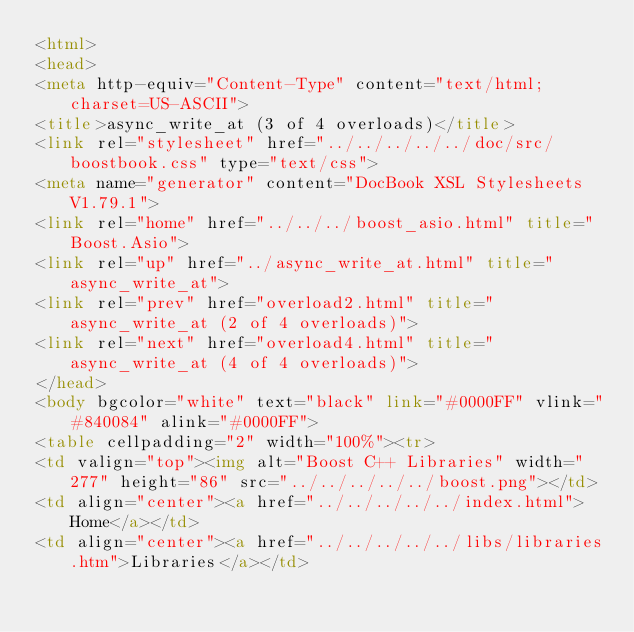Convert code to text. <code><loc_0><loc_0><loc_500><loc_500><_HTML_><html>
<head>
<meta http-equiv="Content-Type" content="text/html; charset=US-ASCII">
<title>async_write_at (3 of 4 overloads)</title>
<link rel="stylesheet" href="../../../../../doc/src/boostbook.css" type="text/css">
<meta name="generator" content="DocBook XSL Stylesheets V1.79.1">
<link rel="home" href="../../../boost_asio.html" title="Boost.Asio">
<link rel="up" href="../async_write_at.html" title="async_write_at">
<link rel="prev" href="overload2.html" title="async_write_at (2 of 4 overloads)">
<link rel="next" href="overload4.html" title="async_write_at (4 of 4 overloads)">
</head>
<body bgcolor="white" text="black" link="#0000FF" vlink="#840084" alink="#0000FF">
<table cellpadding="2" width="100%"><tr>
<td valign="top"><img alt="Boost C++ Libraries" width="277" height="86" src="../../../../../boost.png"></td>
<td align="center"><a href="../../../../../index.html">Home</a></td>
<td align="center"><a href="../../../../../libs/libraries.htm">Libraries</a></td></code> 